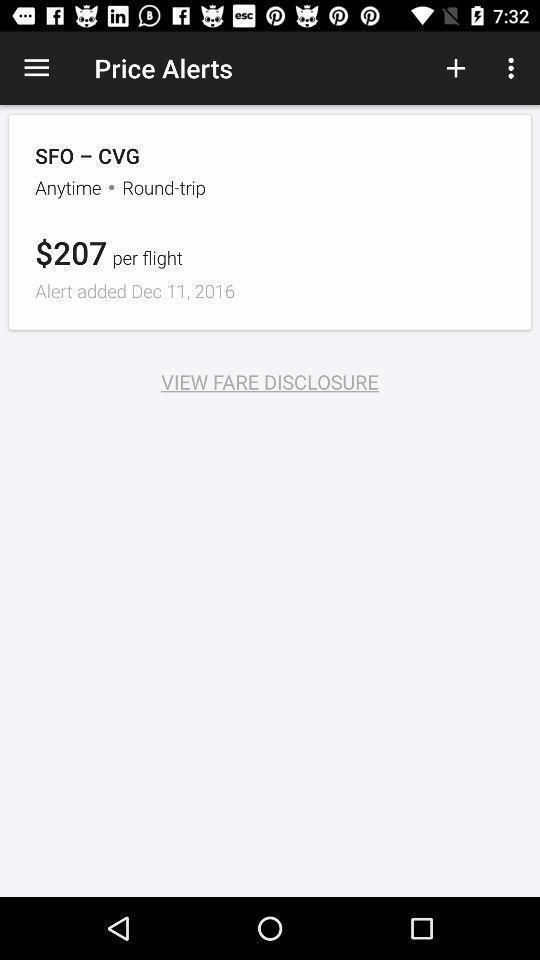Please provide a description for this image. Screen displaying about flight price. 